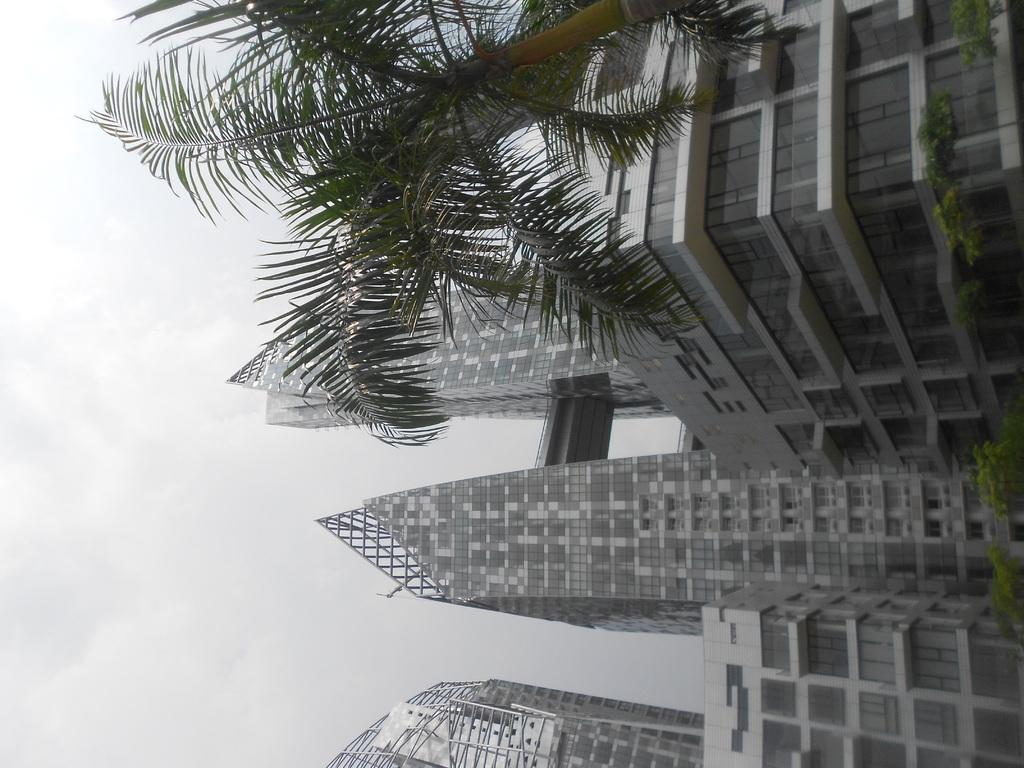What type of structures can be seen in the image? There is a group of buildings in the image. What other natural elements are present in the image? There are trees in the image. What can be seen in the background of the image? The sky is visible in the background of the image. What type of fowl can be seen protesting in the image? There is no fowl or protest present in the image; it features a group of buildings and trees with the sky visible in the background. 